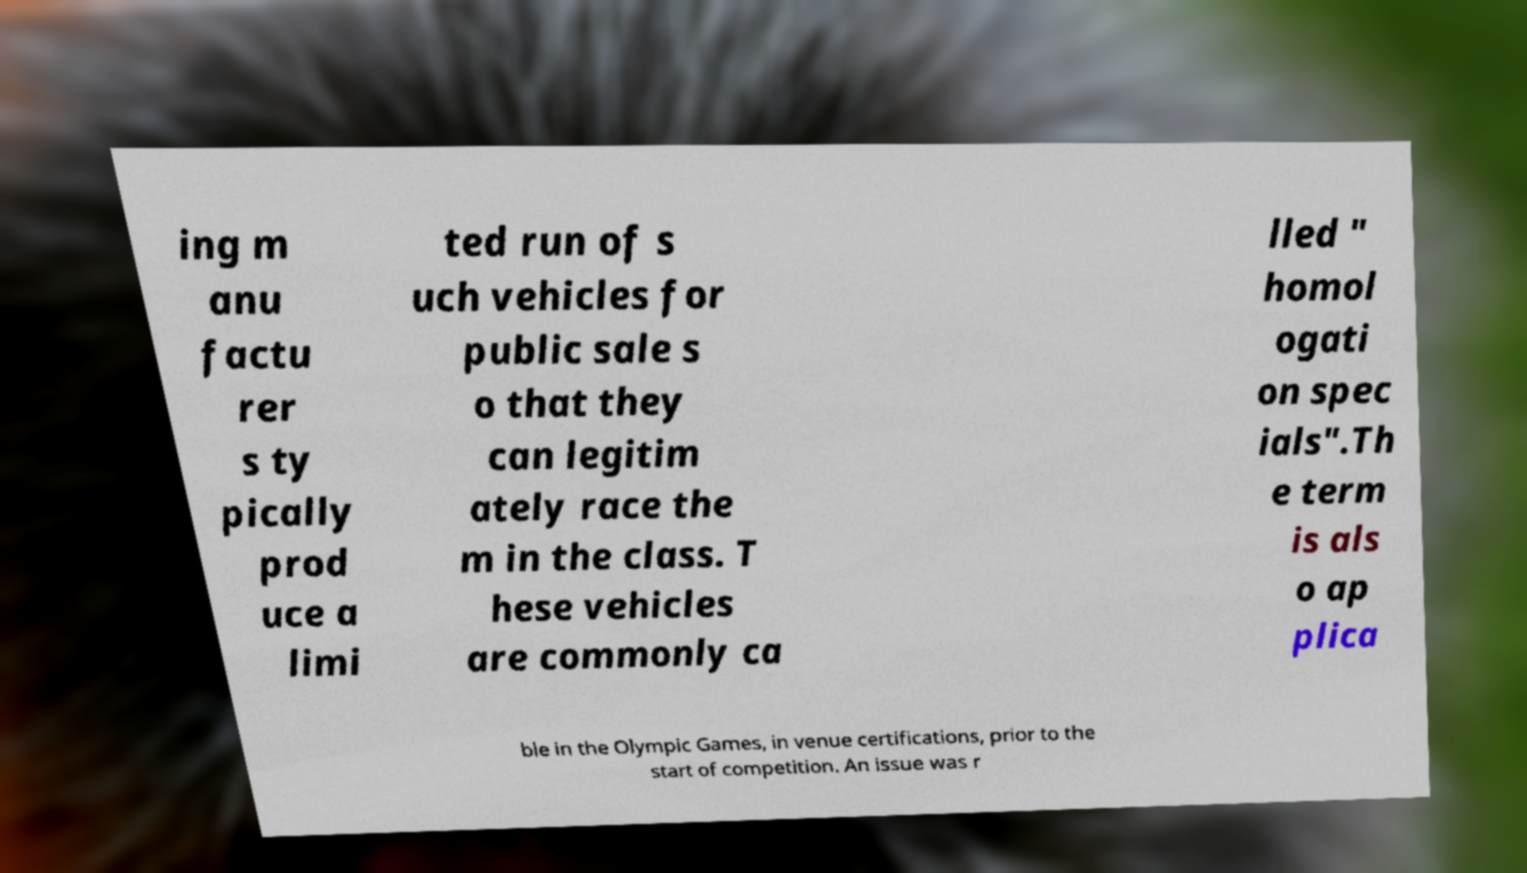What messages or text are displayed in this image? I need them in a readable, typed format. ing m anu factu rer s ty pically prod uce a limi ted run of s uch vehicles for public sale s o that they can legitim ately race the m in the class. T hese vehicles are commonly ca lled " homol ogati on spec ials".Th e term is als o ap plica ble in the Olympic Games, in venue certifications, prior to the start of competition. An issue was r 